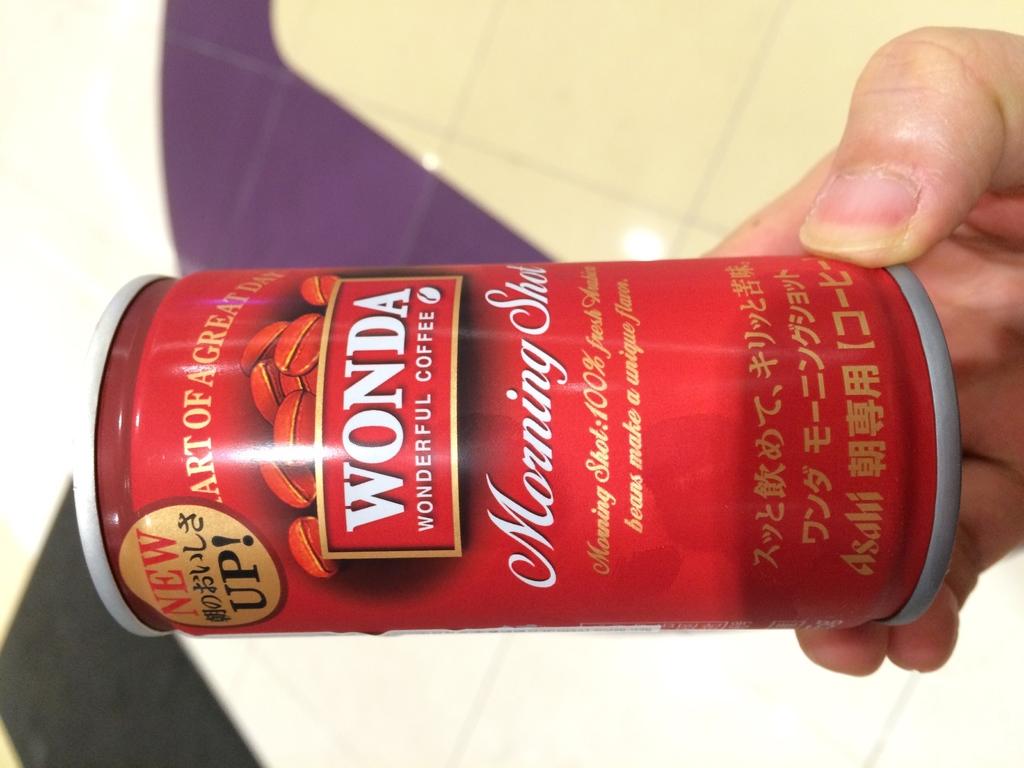What is the name of the beverage?
Your answer should be compact. Wonda. 